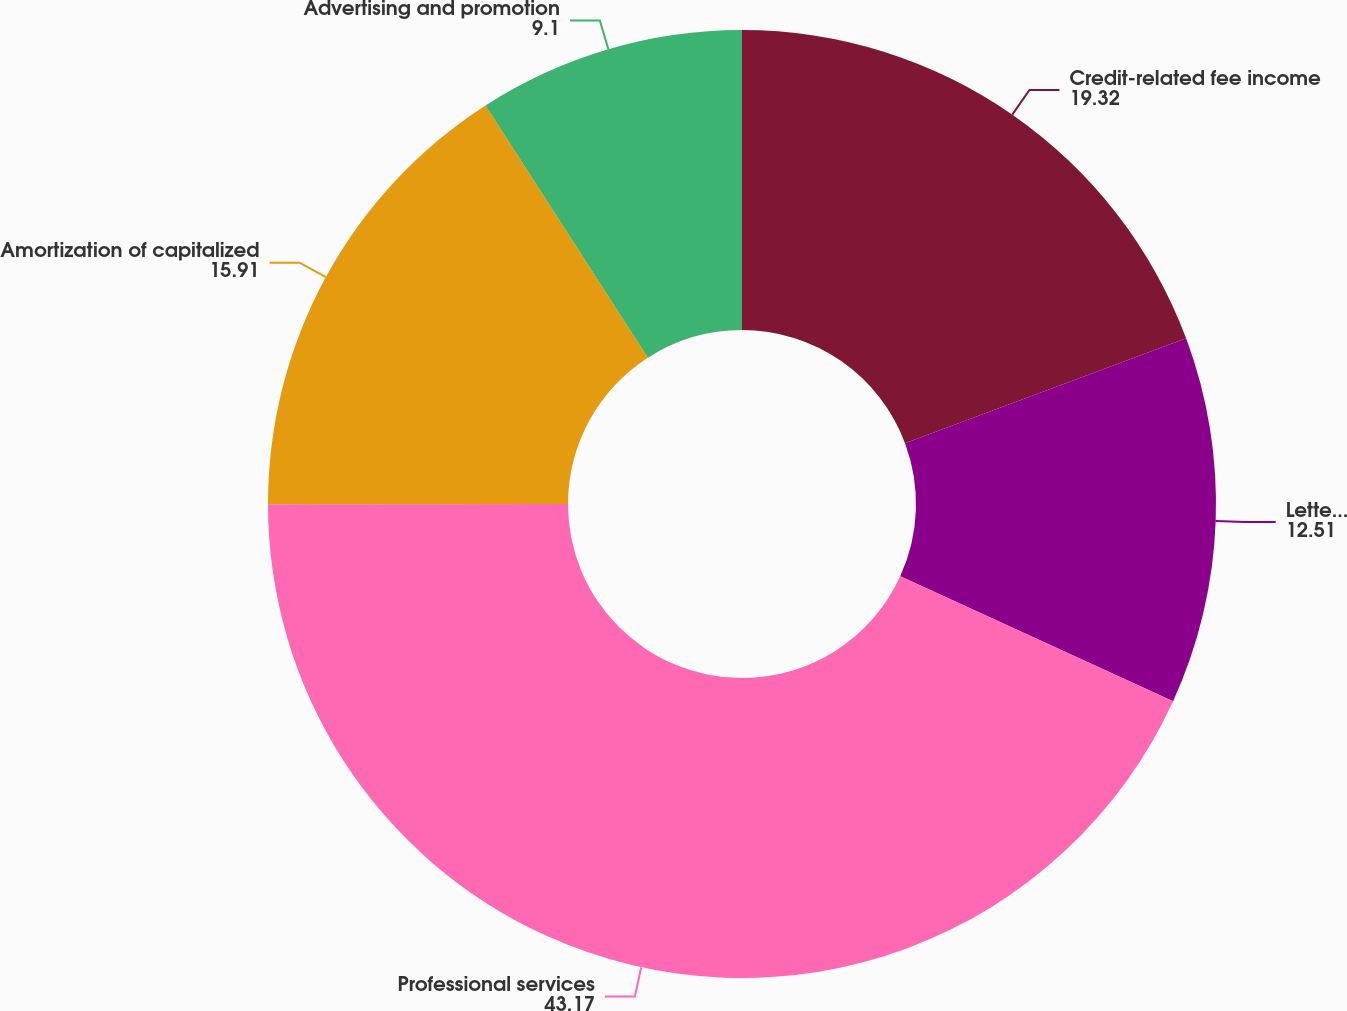Convert chart to OTSL. <chart><loc_0><loc_0><loc_500><loc_500><pie_chart><fcel>Credit-related fee income<fcel>Letter of credit fees<fcel>Professional services<fcel>Amortization of capitalized<fcel>Advertising and promotion<nl><fcel>19.32%<fcel>12.51%<fcel>43.17%<fcel>15.91%<fcel>9.1%<nl></chart> 